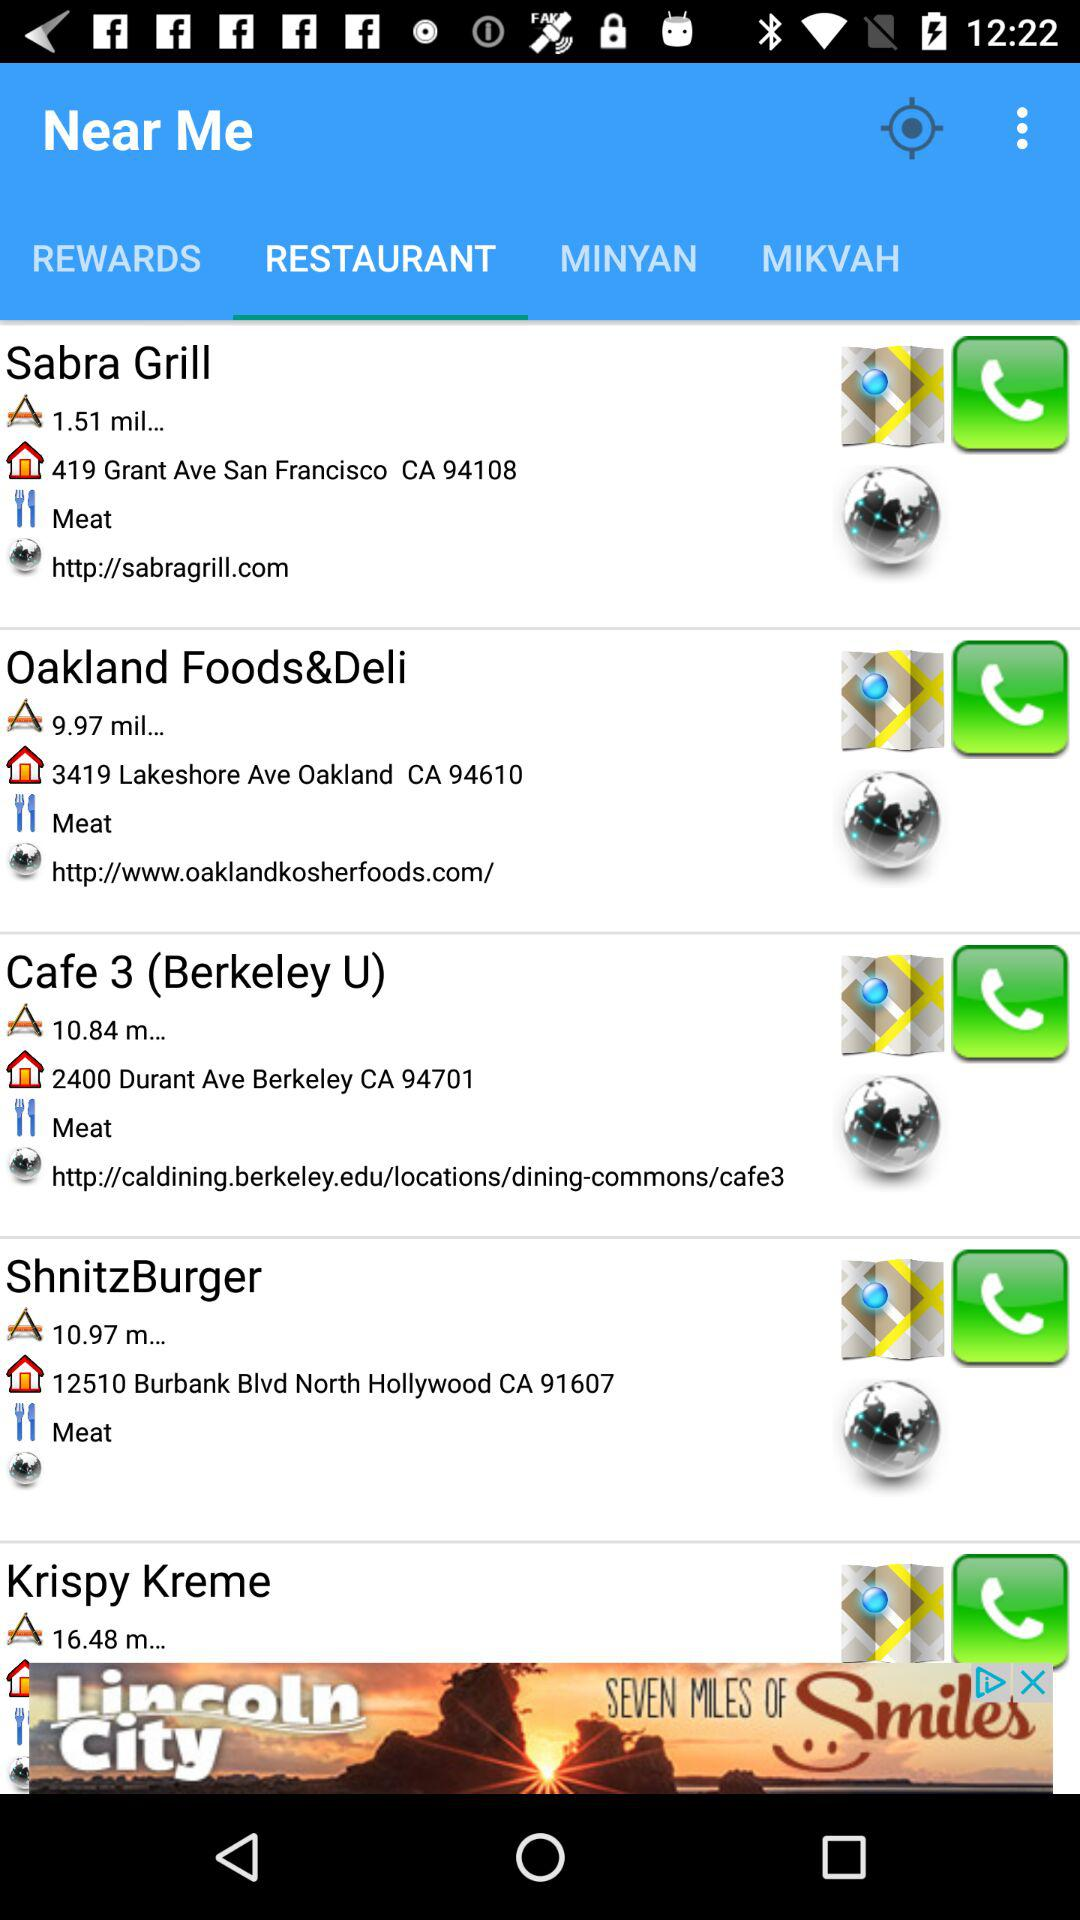How far is Shnitzburger? Shnitzburger is 10.97 miles away. 